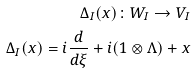<formula> <loc_0><loc_0><loc_500><loc_500>\Delta _ { I } ( x ) \colon W _ { I } \rightarrow V _ { I } \\ \Delta _ { I } ( x ) = i \frac { d } { d \xi } + i ( 1 \otimes \Lambda ) + x</formula> 